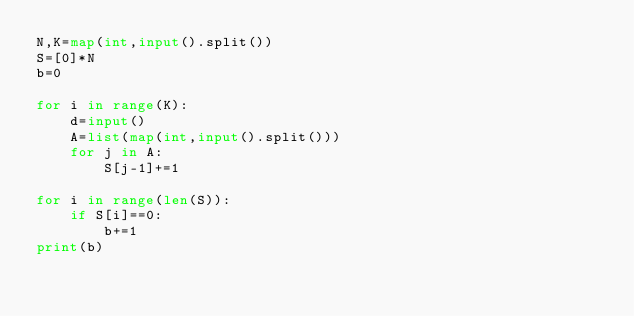<code> <loc_0><loc_0><loc_500><loc_500><_Python_>N,K=map(int,input().split())
S=[0]*N
b=0

for i in range(K):
    d=input()
    A=list(map(int,input().split()))
    for j in A:
        S[j-1]+=1

for i in range(len(S)):
    if S[i]==0:
        b+=1
print(b)</code> 